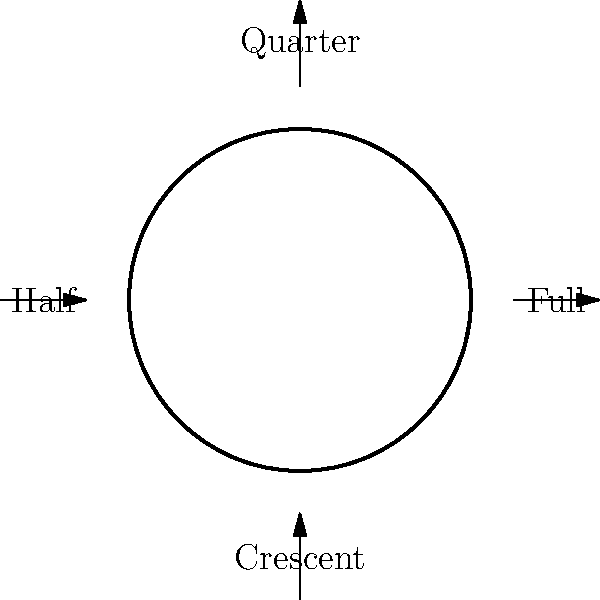As a local council member working on economic development initiatives, you're assessing the impact of lunar phases on agricultural practices. Which phase of the moon is associated with the highest tidal range, potentially affecting coastal farming and fishing activities in your village? To answer this question, let's consider the relationship between lunar phases and tidal ranges:

1. Lunar phases are caused by the moon's position relative to the Earth and Sun.

2. Tides are primarily influenced by the gravitational pull of the moon and, to a lesser extent, the sun.

3. The highest tides, called spring tides, occur when the gravitational forces of the moon and sun align.

4. This alignment happens during two specific lunar phases:
   a) Full Moon: When the Earth is between the Sun and Moon
   b) New Moon: When the Moon is between the Earth and Sun

5. During these phases, the gravitational pull of the moon and sun work together, creating higher high tides and lower low tides.

6. The full moon is the phase shown in the diagram that appears as a complete circle.

7. While both full and new moons cause spring tides, the full moon is more easily observable and often used as a reference point in traditional agricultural practices.

Therefore, the full moon phase is associated with the highest tidal range, which could significantly impact coastal farming and fishing activities in your village.
Answer: Full moon 